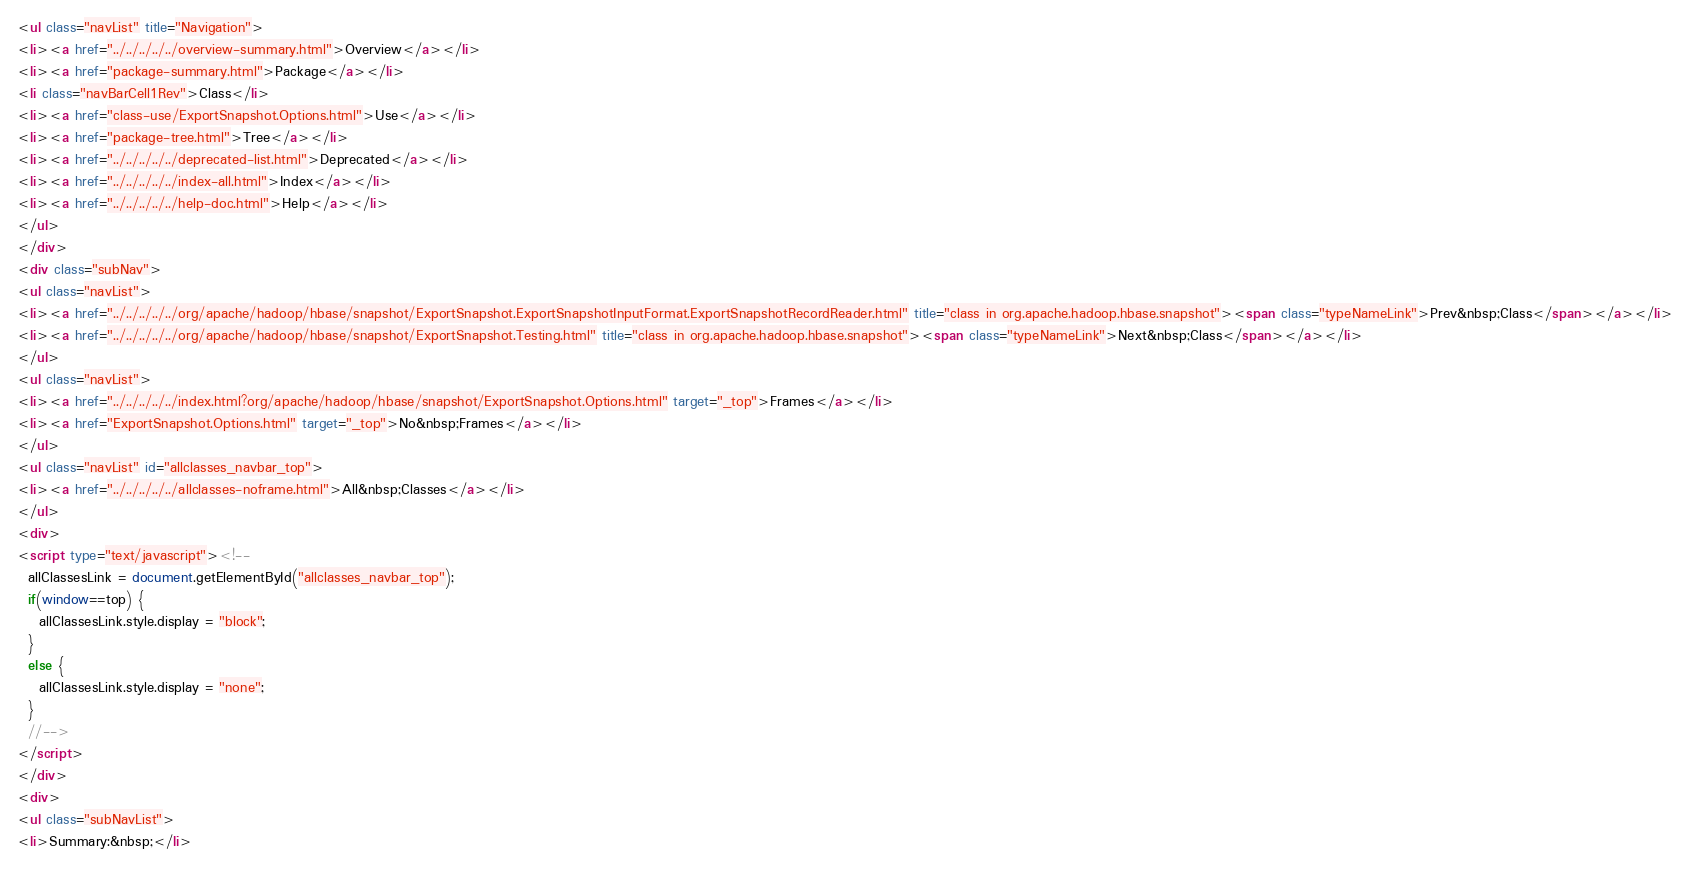<code> <loc_0><loc_0><loc_500><loc_500><_HTML_><ul class="navList" title="Navigation">
<li><a href="../../../../../overview-summary.html">Overview</a></li>
<li><a href="package-summary.html">Package</a></li>
<li class="navBarCell1Rev">Class</li>
<li><a href="class-use/ExportSnapshot.Options.html">Use</a></li>
<li><a href="package-tree.html">Tree</a></li>
<li><a href="../../../../../deprecated-list.html">Deprecated</a></li>
<li><a href="../../../../../index-all.html">Index</a></li>
<li><a href="../../../../../help-doc.html">Help</a></li>
</ul>
</div>
<div class="subNav">
<ul class="navList">
<li><a href="../../../../../org/apache/hadoop/hbase/snapshot/ExportSnapshot.ExportSnapshotInputFormat.ExportSnapshotRecordReader.html" title="class in org.apache.hadoop.hbase.snapshot"><span class="typeNameLink">Prev&nbsp;Class</span></a></li>
<li><a href="../../../../../org/apache/hadoop/hbase/snapshot/ExportSnapshot.Testing.html" title="class in org.apache.hadoop.hbase.snapshot"><span class="typeNameLink">Next&nbsp;Class</span></a></li>
</ul>
<ul class="navList">
<li><a href="../../../../../index.html?org/apache/hadoop/hbase/snapshot/ExportSnapshot.Options.html" target="_top">Frames</a></li>
<li><a href="ExportSnapshot.Options.html" target="_top">No&nbsp;Frames</a></li>
</ul>
<ul class="navList" id="allclasses_navbar_top">
<li><a href="../../../../../allclasses-noframe.html">All&nbsp;Classes</a></li>
</ul>
<div>
<script type="text/javascript"><!--
  allClassesLink = document.getElementById("allclasses_navbar_top");
  if(window==top) {
    allClassesLink.style.display = "block";
  }
  else {
    allClassesLink.style.display = "none";
  }
  //-->
</script>
</div>
<div>
<ul class="subNavList">
<li>Summary:&nbsp;</li></code> 